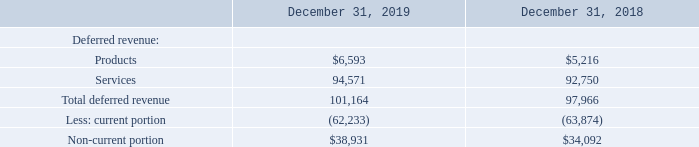Deferred revenue primarily consists of amounts that have been invoiced but not yet been recognized as revenue and consists of performance obligations pertaining to support and subscription services. During the years ended December 31, 2019 and 2018, we recognized revenue of $63.2 million and $60.2 million, related to deferred revenue at the beginning of the period.
Deferred revenue consisted of the following (in thousands):
What does deferred revenue refer to? Deferred revenue primarily consists of amounts that have been invoiced but not yet been recognized as revenue and consists of performance obligations pertaining to support and subscription services. What is the revenue recognized related to deferred revenue in 2019? $60.2 million. What is the revenue recognized related to deferred revenue in 2018? $63.2 million. What proportion of the revenue recognized related to deferred revenue is the non-current portion of the deferred revenue in 2019?
Answer scale should be: percent. (63.2 million - 38,931 thousand)/38,931 thousand 
Answer: 62.34. What is the percentage change in total deferred revenue 2018 and 2019?
Answer scale should be: percent. (101,164 - 97,966)/97,966 
Answer: 3.26. What is the total non-current portion of the deferred revenue between 2018 and 2019?
Answer scale should be: thousand. 101,164+97,966
Answer: 199130. 